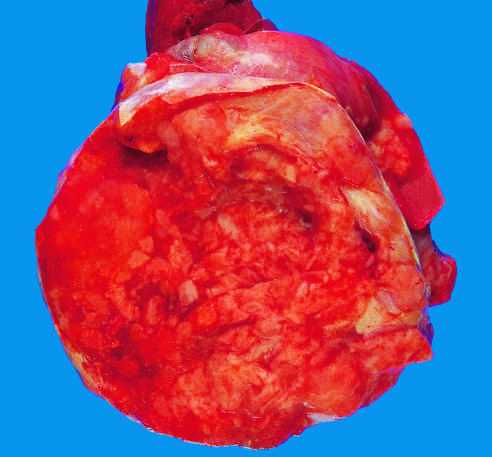what are large and hyperchromatic?
Answer the question using a single word or phrase. The nuclei 